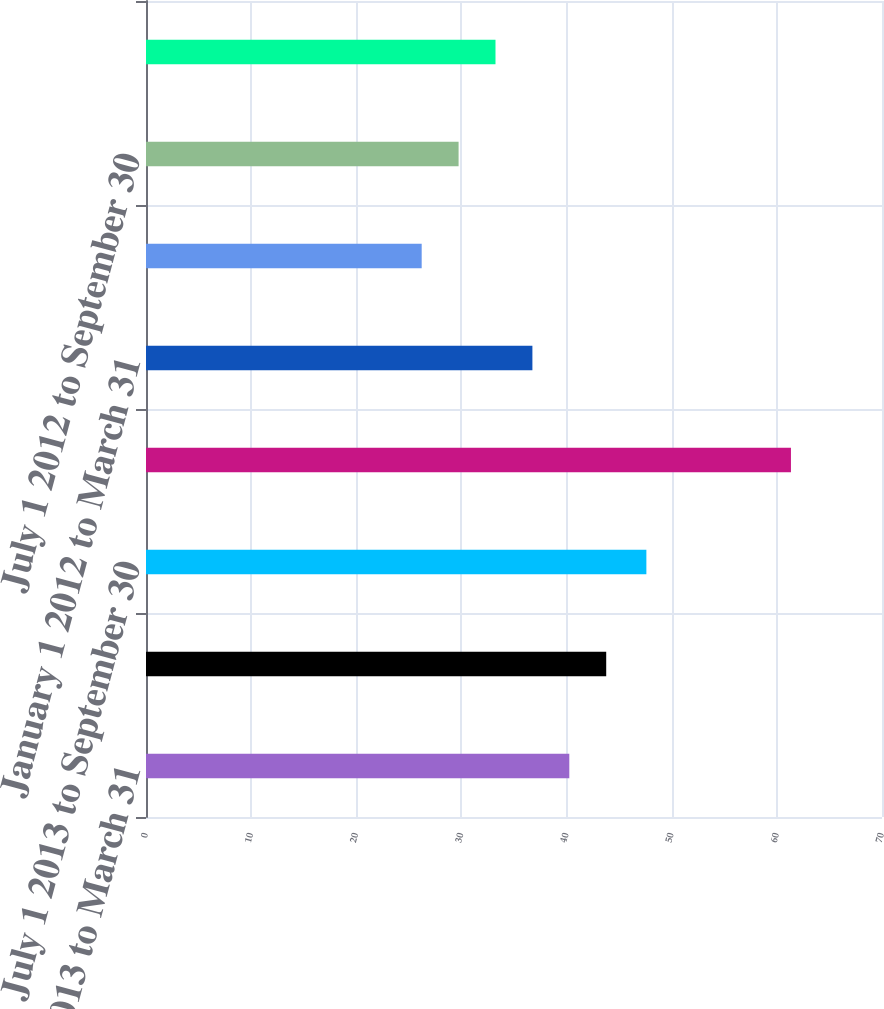<chart> <loc_0><loc_0><loc_500><loc_500><bar_chart><fcel>January 1 2013 to March 31<fcel>April 1 2013 to June 30 2013<fcel>July 1 2013 to September 30<fcel>October 1 2013 to December 31<fcel>January 1 2012 to March 31<fcel>April 1 2012 to June 30 2012<fcel>July 1 2012 to September 30<fcel>October 1 2012 to December 31<nl><fcel>40.26<fcel>43.77<fcel>47.59<fcel>61.34<fcel>36.75<fcel>26.22<fcel>29.73<fcel>33.24<nl></chart> 